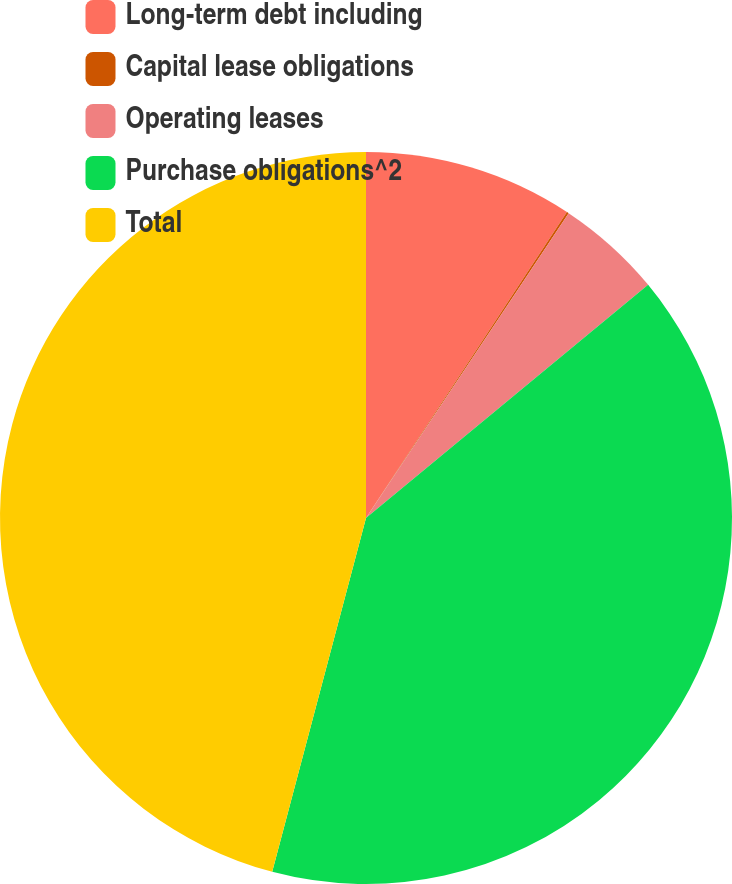Convert chart. <chart><loc_0><loc_0><loc_500><loc_500><pie_chart><fcel>Long-term debt including<fcel>Capital lease obligations<fcel>Operating leases<fcel>Purchase obligations^2<fcel>Total<nl><fcel>9.25%<fcel>0.09%<fcel>4.67%<fcel>40.12%<fcel>45.88%<nl></chart> 